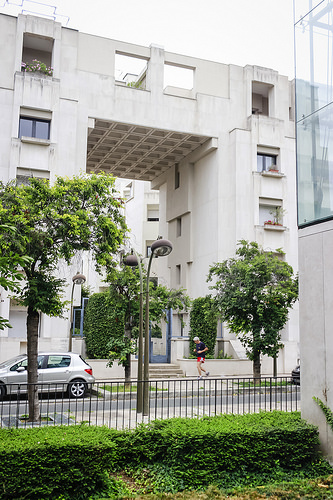<image>
Is there a man under the street lamp? No. The man is not positioned under the street lamp. The vertical relationship between these objects is different. 